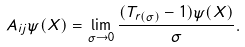<formula> <loc_0><loc_0><loc_500><loc_500>A _ { i j } \psi ( X ) = \lim _ { \sigma \to 0 } \frac { ( T _ { r ( \sigma ) } - 1 ) \psi ( X ) } { \sigma } .</formula> 